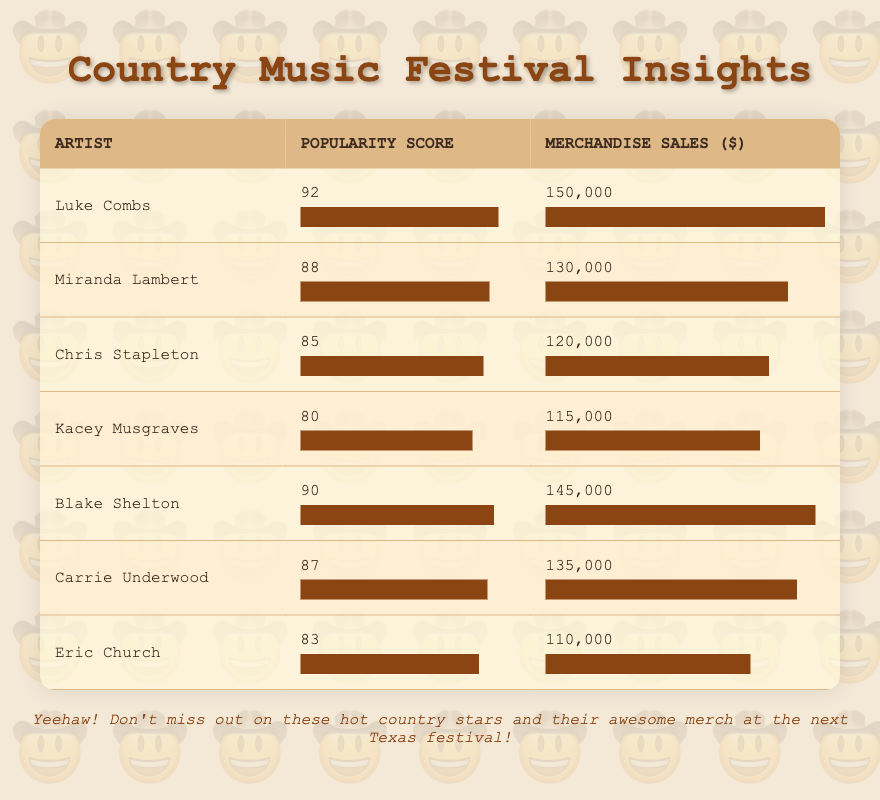What is the merchandise sales figure for Carrie Underwood? The table lists Carrie Underwood's merchandise sales as $135,000.
Answer: 135,000 Who has the highest popularity score? Luke Combs has the highest popularity score of 92, according to the table.
Answer: Luke Combs What is the average merchandise sales of the artists listed in the table? To find the average, sum the merchandise sales: 150,000 + 130,000 + 120,000 + 115,000 + 145,000 + 135,000 + 110,000 = 1,005,000. Divide by the number of artists (7): 1,005,000 / 7 = 143,571.43.
Answer: 143,571.43 Is Kacey Musgraves more popular than Eric Church? Kacey Musgraves has a popularity score of 80, while Eric Church has a score of 83, indicating that Kacey is less popular than Eric.
Answer: No What is the difference in merchandise sales between Luke Combs and Chris Stapleton? Luke Combs has merchandise sales of $150,000, and Chris Stapleton has $120,000. The difference is calculated as $150,000 - $120,000 = $30,000.
Answer: 30,000 Which artist has the lowest merchandise sales and what is that amount? Eric Church has the lowest merchandise sales of $110,000, as listed in the table.
Answer: Eric Church, 110,000 Are there any artists with merchandise sales above $140,000? Yes, both Luke Combs and Blake Shelton have merchandise sales above $140,000, with figures of $150,000 and $145,000, respectively.
Answer: Yes What is the total popularity score of all the artists listed? Adding the popularity scores: 92 + 88 + 85 + 80 + 90 + 87 + 83 = 605.
Answer: 605 Which artist has a popularity score closest to the average popularity score of the group? The average popularity score is calculated as 605 / 7 = 86.43. The scores closest to this average are Miranda Lambert (88) and Carrie Underwood (87).
Answer: Miranda Lambert, Carrie Underwood 